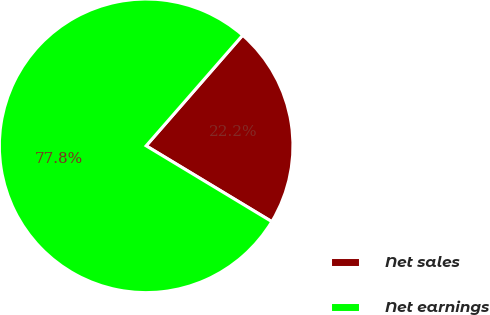Convert chart. <chart><loc_0><loc_0><loc_500><loc_500><pie_chart><fcel>Net sales<fcel>Net earnings<nl><fcel>22.22%<fcel>77.78%<nl></chart> 